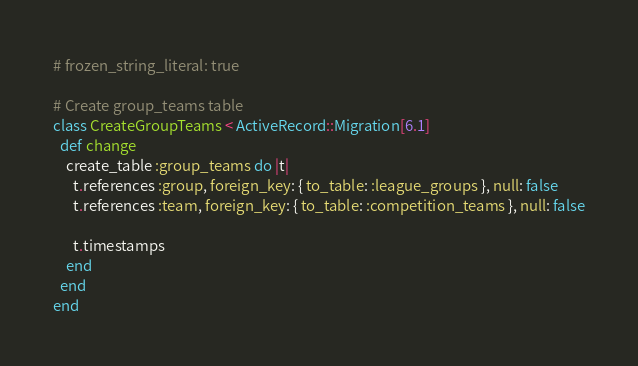<code> <loc_0><loc_0><loc_500><loc_500><_Ruby_># frozen_string_literal: true

# Create group_teams table
class CreateGroupTeams < ActiveRecord::Migration[6.1]
  def change
    create_table :group_teams do |t|
      t.references :group, foreign_key: { to_table: :league_groups }, null: false
      t.references :team, foreign_key: { to_table: :competition_teams }, null: false

      t.timestamps
    end
  end
end
</code> 